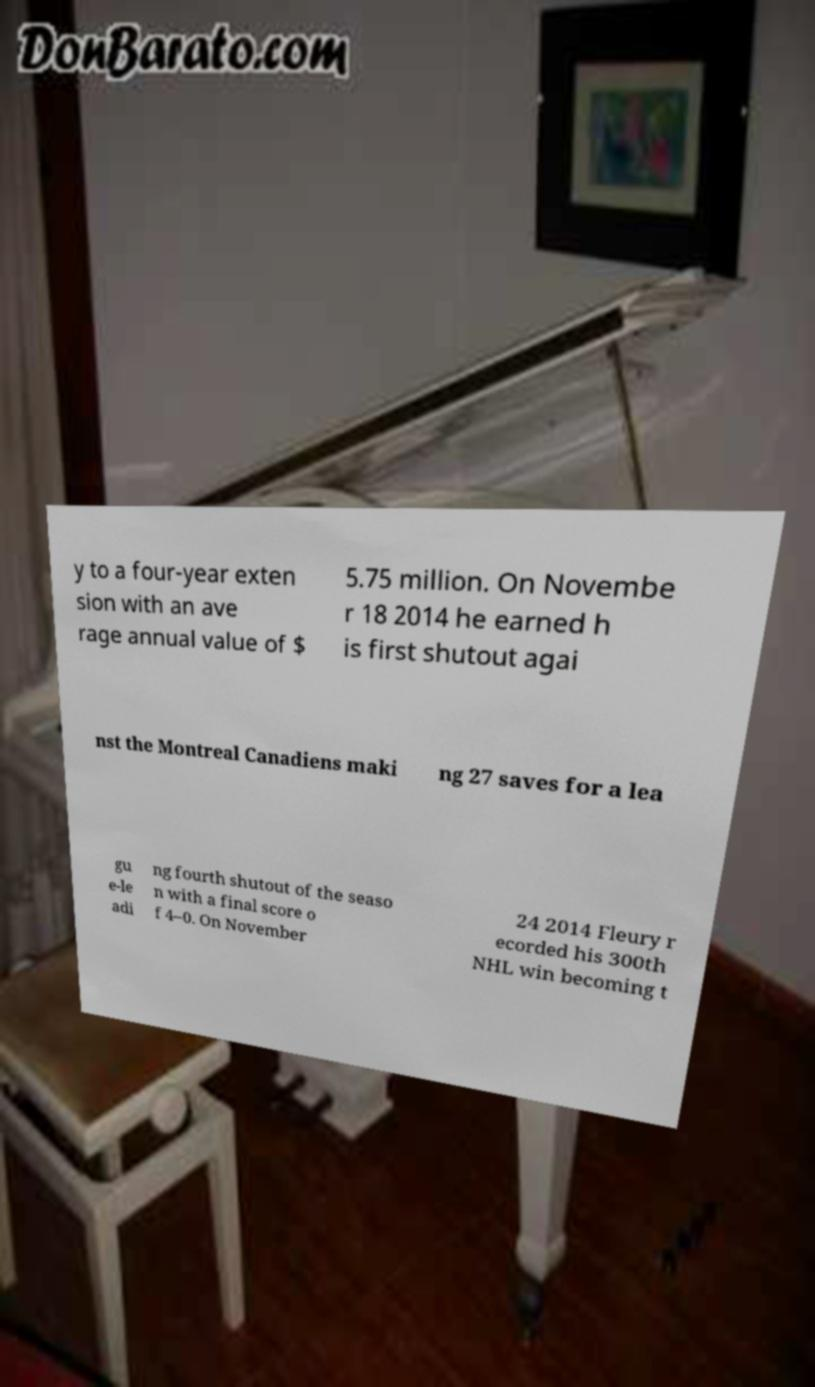Can you read and provide the text displayed in the image?This photo seems to have some interesting text. Can you extract and type it out for me? y to a four-year exten sion with an ave rage annual value of $ 5.75 million. On Novembe r 18 2014 he earned h is first shutout agai nst the Montreal Canadiens maki ng 27 saves for a lea gu e-le adi ng fourth shutout of the seaso n with a final score o f 4–0. On November 24 2014 Fleury r ecorded his 300th NHL win becoming t 